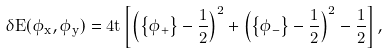Convert formula to latex. <formula><loc_0><loc_0><loc_500><loc_500>\delta E ( \phi _ { x } , \phi _ { y } ) = 4 t \left [ \left ( \left \{ \phi _ { + } \right \} - \frac { 1 } { 2 } \right ) ^ { 2 } + \left ( \left \{ \phi _ { - } \right \} - \frac { 1 } { 2 } \right ) ^ { 2 } - \frac { 1 } { 2 } \right ] ,</formula> 